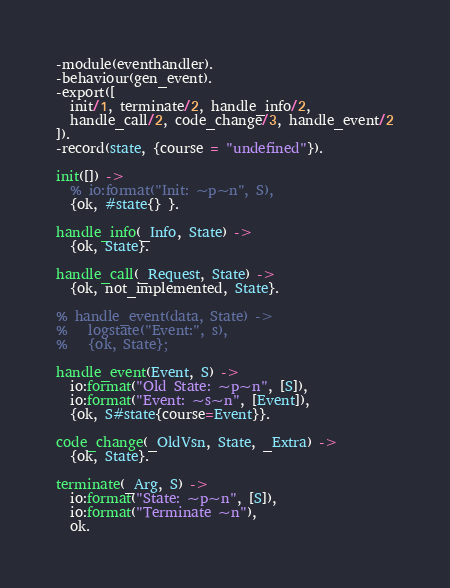Convert code to text. <code><loc_0><loc_0><loc_500><loc_500><_Erlang_>-module(eventhandler).
-behaviour(gen_event).
-export([
  init/1, terminate/2, handle_info/2,
  handle_call/2, code_change/3, handle_event/2
]).
-record(state, {course = "undefined"}).

init([]) ->
  % io:format("Init: ~p~n", S),
  {ok, #state{} }.

handle_info(_Info, State) ->
  {ok, State}.

handle_call(_Request, State) ->
  {ok, not_implemented, State}.

% handle_event(data, State) ->
%   logstate("Event:", s),
%   {ok, State};

handle_event(Event, S) ->
  io:format("Old State: ~p~n", [S]),
  io:format("Event: ~s~n", [Event]),
  {ok, S#state{course=Event}}.

code_change(_OldVsn, State, _Extra) ->
  {ok, State}.

terminate(_Arg, S) ->
  io:format("State: ~p~n", [S]),
  io:format("Terminate ~n"),
  ok.
</code> 